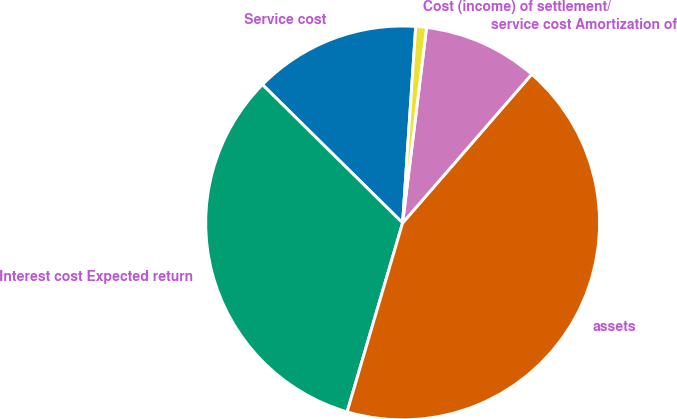Convert chart to OTSL. <chart><loc_0><loc_0><loc_500><loc_500><pie_chart><fcel>Service cost<fcel>Interest cost Expected return<fcel>assets<fcel>service cost Amortization of<fcel>Cost (income) of settlement/<nl><fcel>13.67%<fcel>32.85%<fcel>43.17%<fcel>9.44%<fcel>0.88%<nl></chart> 